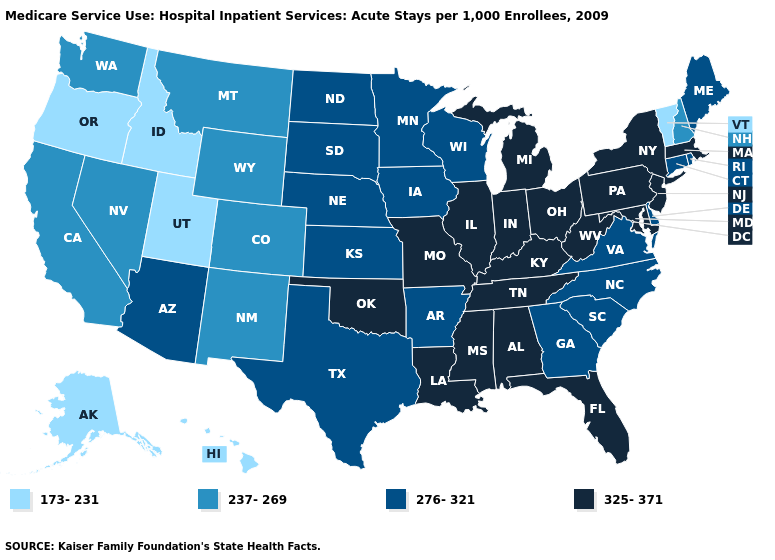Does Maine have the lowest value in the Northeast?
Be succinct. No. What is the highest value in the Northeast ?
Quick response, please. 325-371. Does the first symbol in the legend represent the smallest category?
Short answer required. Yes. Does Wisconsin have the same value as Florida?
Give a very brief answer. No. Which states have the lowest value in the South?
Concise answer only. Arkansas, Delaware, Georgia, North Carolina, South Carolina, Texas, Virginia. Name the states that have a value in the range 173-231?
Answer briefly. Alaska, Hawaii, Idaho, Oregon, Utah, Vermont. What is the highest value in the USA?
Quick response, please. 325-371. Name the states that have a value in the range 237-269?
Write a very short answer. California, Colorado, Montana, Nevada, New Hampshire, New Mexico, Washington, Wyoming. Among the states that border Delaware , which have the lowest value?
Answer briefly. Maryland, New Jersey, Pennsylvania. Name the states that have a value in the range 237-269?
Short answer required. California, Colorado, Montana, Nevada, New Hampshire, New Mexico, Washington, Wyoming. Does Nebraska have the same value as North Dakota?
Keep it brief. Yes. Name the states that have a value in the range 276-321?
Keep it brief. Arizona, Arkansas, Connecticut, Delaware, Georgia, Iowa, Kansas, Maine, Minnesota, Nebraska, North Carolina, North Dakota, Rhode Island, South Carolina, South Dakota, Texas, Virginia, Wisconsin. What is the lowest value in the South?
Short answer required. 276-321. Name the states that have a value in the range 237-269?
Concise answer only. California, Colorado, Montana, Nevada, New Hampshire, New Mexico, Washington, Wyoming. Name the states that have a value in the range 173-231?
Answer briefly. Alaska, Hawaii, Idaho, Oregon, Utah, Vermont. 